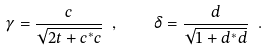Convert formula to latex. <formula><loc_0><loc_0><loc_500><loc_500>\gamma = \frac { c } { \sqrt { 2 t + c ^ { * } c } } \ , \quad \delta = \frac { d } { \sqrt { 1 + d ^ { * } d } } \ .</formula> 